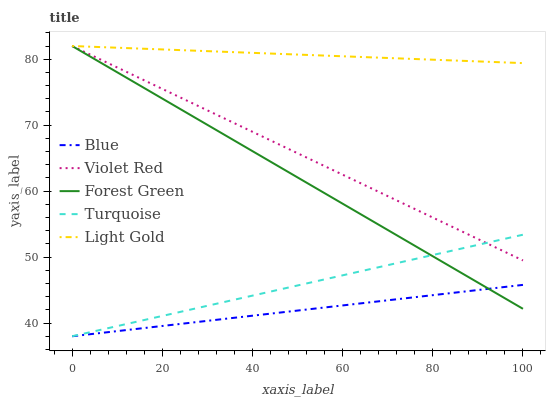Does Blue have the minimum area under the curve?
Answer yes or no. Yes. Does Light Gold have the maximum area under the curve?
Answer yes or no. Yes. Does Violet Red have the minimum area under the curve?
Answer yes or no. No. Does Violet Red have the maximum area under the curve?
Answer yes or no. No. Is Light Gold the smoothest?
Answer yes or no. Yes. Is Forest Green the roughest?
Answer yes or no. Yes. Is Violet Red the smoothest?
Answer yes or no. No. Is Violet Red the roughest?
Answer yes or no. No. Does Violet Red have the lowest value?
Answer yes or no. No. Does Forest Green have the highest value?
Answer yes or no. Yes. Does Turquoise have the highest value?
Answer yes or no. No. Is Turquoise less than Light Gold?
Answer yes or no. Yes. Is Violet Red greater than Blue?
Answer yes or no. Yes. Does Forest Green intersect Light Gold?
Answer yes or no. Yes. Is Forest Green less than Light Gold?
Answer yes or no. No. Is Forest Green greater than Light Gold?
Answer yes or no. No. Does Turquoise intersect Light Gold?
Answer yes or no. No. 